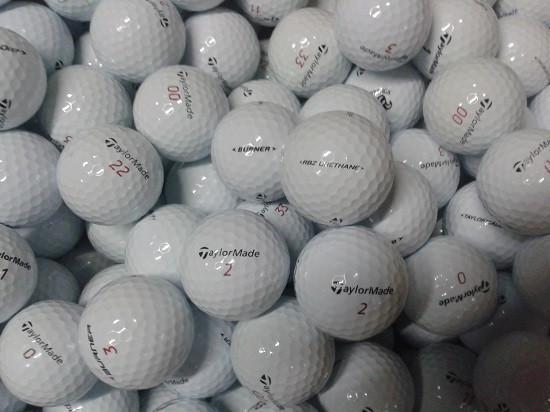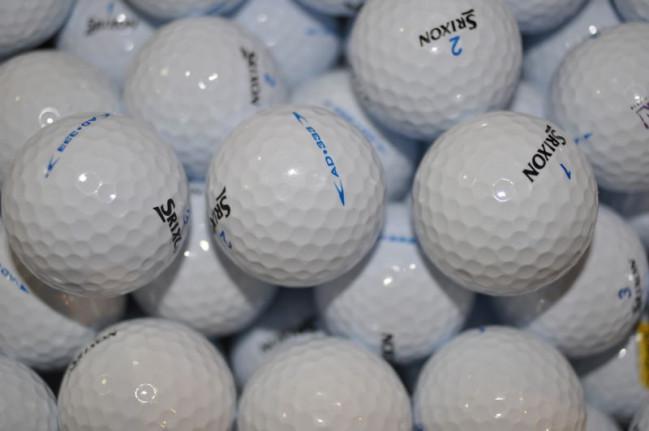The first image is the image on the left, the second image is the image on the right. Examine the images to the left and right. Is the description "The golfballs in the image on the right are not in shadow." accurate? Answer yes or no. No. 